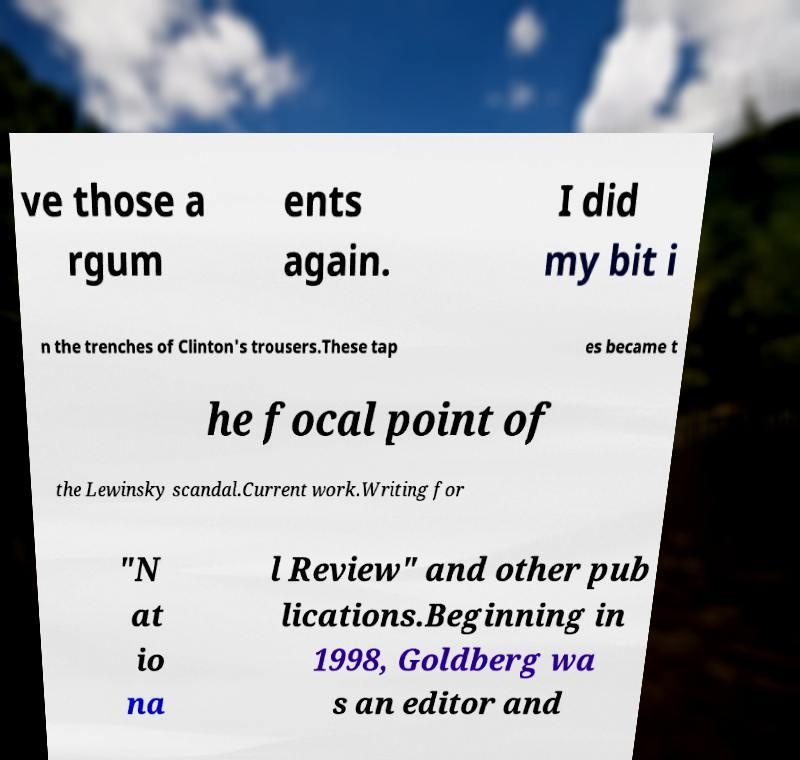What messages or text are displayed in this image? I need them in a readable, typed format. ve those a rgum ents again. I did my bit i n the trenches of Clinton's trousers.These tap es became t he focal point of the Lewinsky scandal.Current work.Writing for "N at io na l Review" and other pub lications.Beginning in 1998, Goldberg wa s an editor and 